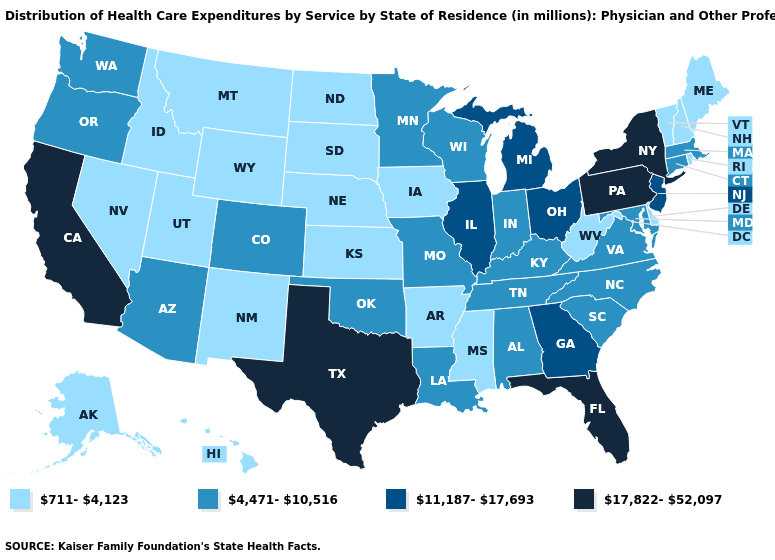Which states hav the highest value in the MidWest?
Short answer required. Illinois, Michigan, Ohio. Which states hav the highest value in the South?
Keep it brief. Florida, Texas. Does North Carolina have the lowest value in the USA?
Give a very brief answer. No. What is the value of Arizona?
Answer briefly. 4,471-10,516. Does the map have missing data?
Be succinct. No. Does Idaho have a lower value than South Carolina?
Be succinct. Yes. What is the highest value in states that border Louisiana?
Write a very short answer. 17,822-52,097. Does the first symbol in the legend represent the smallest category?
Be succinct. Yes. Does Indiana have a lower value than Florida?
Quick response, please. Yes. Does Arizona have a higher value than Alaska?
Concise answer only. Yes. What is the value of Alaska?
Quick response, please. 711-4,123. What is the value of Arkansas?
Short answer required. 711-4,123. What is the highest value in the Northeast ?
Keep it brief. 17,822-52,097. What is the value of Hawaii?
Answer briefly. 711-4,123. Name the states that have a value in the range 11,187-17,693?
Short answer required. Georgia, Illinois, Michigan, New Jersey, Ohio. 